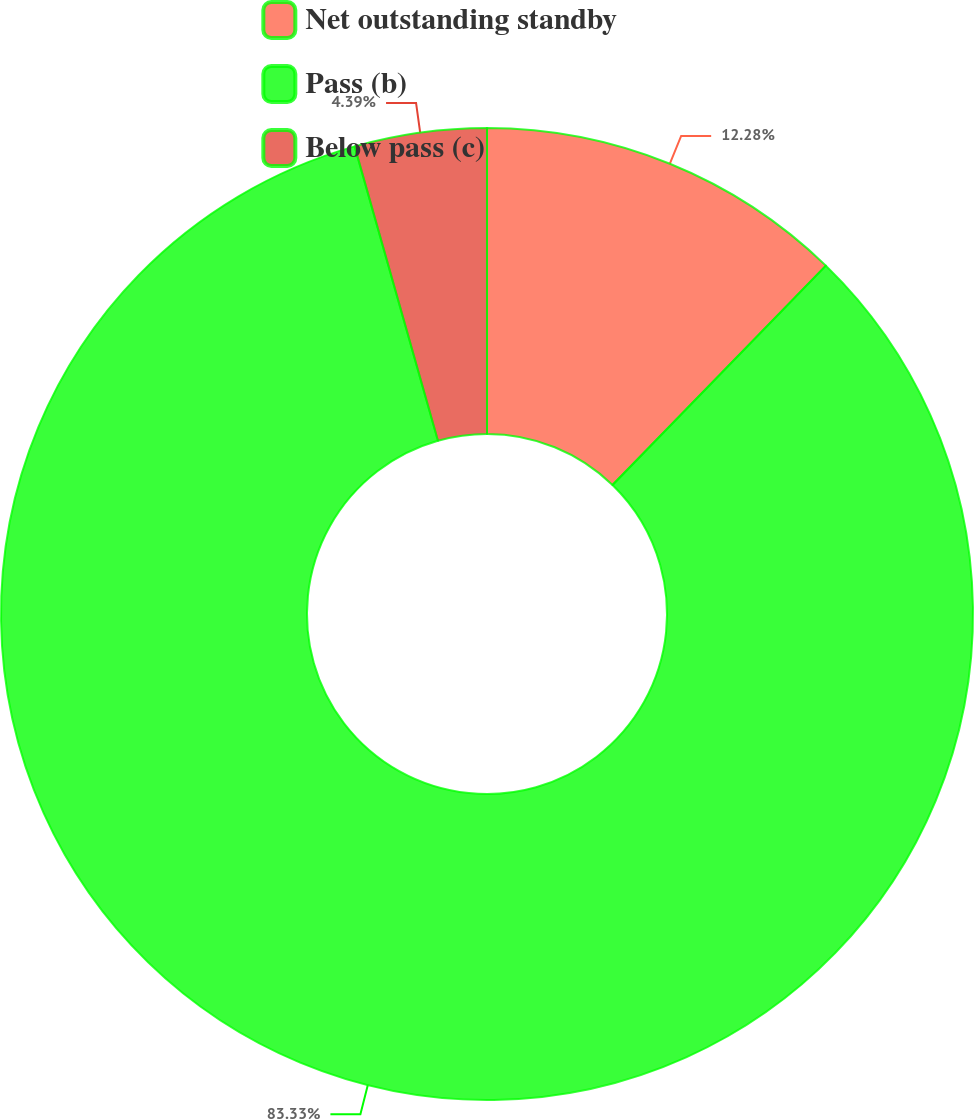<chart> <loc_0><loc_0><loc_500><loc_500><pie_chart><fcel>Net outstanding standby<fcel>Pass (b)<fcel>Below pass (c)<nl><fcel>12.28%<fcel>83.33%<fcel>4.39%<nl></chart> 